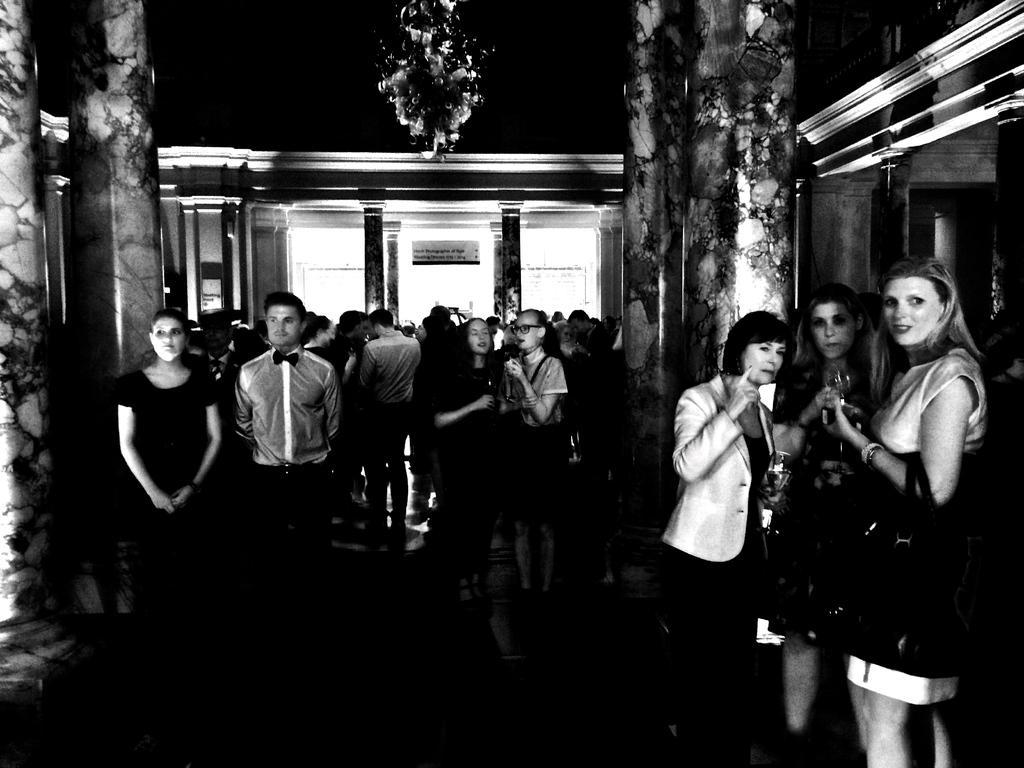How would you summarize this image in a sentence or two? The image looks like an edited picture. In the foreground of the picture we can see pillars, people and chandelier. In the background we can see doors, wall, posters and other objects. In the middle of the picture there are people. 